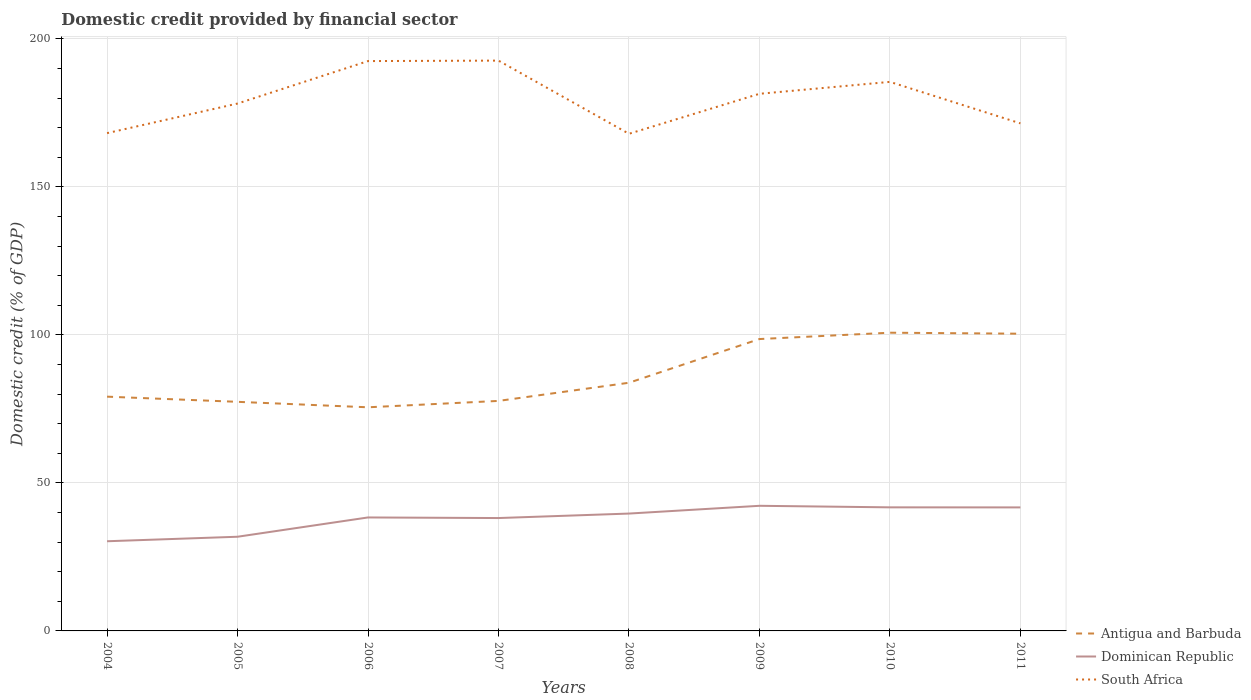How many different coloured lines are there?
Provide a short and direct response. 3. Is the number of lines equal to the number of legend labels?
Your answer should be compact. Yes. Across all years, what is the maximum domestic credit in Dominican Republic?
Keep it short and to the point. 30.29. What is the total domestic credit in Antigua and Barbuda in the graph?
Keep it short and to the point. -21.6. What is the difference between the highest and the second highest domestic credit in South Africa?
Provide a succinct answer. 24.72. What is the difference between the highest and the lowest domestic credit in Dominican Republic?
Offer a terse response. 6. Is the domestic credit in Dominican Republic strictly greater than the domestic credit in South Africa over the years?
Give a very brief answer. Yes. How many lines are there?
Keep it short and to the point. 3. Where does the legend appear in the graph?
Your response must be concise. Bottom right. How many legend labels are there?
Make the answer very short. 3. How are the legend labels stacked?
Your response must be concise. Vertical. What is the title of the graph?
Your answer should be compact. Domestic credit provided by financial sector. What is the label or title of the Y-axis?
Make the answer very short. Domestic credit (% of GDP). What is the Domestic credit (% of GDP) in Antigua and Barbuda in 2004?
Your answer should be compact. 79.14. What is the Domestic credit (% of GDP) of Dominican Republic in 2004?
Give a very brief answer. 30.29. What is the Domestic credit (% of GDP) in South Africa in 2004?
Offer a terse response. 168.16. What is the Domestic credit (% of GDP) in Antigua and Barbuda in 2005?
Offer a terse response. 77.39. What is the Domestic credit (% of GDP) of Dominican Republic in 2005?
Your answer should be very brief. 31.81. What is the Domestic credit (% of GDP) of South Africa in 2005?
Keep it short and to the point. 178.16. What is the Domestic credit (% of GDP) in Antigua and Barbuda in 2006?
Your answer should be very brief. 75.54. What is the Domestic credit (% of GDP) in Dominican Republic in 2006?
Offer a terse response. 38.33. What is the Domestic credit (% of GDP) of South Africa in 2006?
Give a very brief answer. 192.5. What is the Domestic credit (% of GDP) of Antigua and Barbuda in 2007?
Keep it short and to the point. 77.7. What is the Domestic credit (% of GDP) in Dominican Republic in 2007?
Provide a succinct answer. 38.13. What is the Domestic credit (% of GDP) in South Africa in 2007?
Provide a short and direct response. 192.66. What is the Domestic credit (% of GDP) of Antigua and Barbuda in 2008?
Your answer should be very brief. 83.84. What is the Domestic credit (% of GDP) of Dominican Republic in 2008?
Keep it short and to the point. 39.64. What is the Domestic credit (% of GDP) in South Africa in 2008?
Your answer should be very brief. 167.94. What is the Domestic credit (% of GDP) in Antigua and Barbuda in 2009?
Provide a succinct answer. 98.6. What is the Domestic credit (% of GDP) in Dominican Republic in 2009?
Make the answer very short. 42.27. What is the Domestic credit (% of GDP) of South Africa in 2009?
Your answer should be compact. 181.45. What is the Domestic credit (% of GDP) in Antigua and Barbuda in 2010?
Keep it short and to the point. 100.74. What is the Domestic credit (% of GDP) in Dominican Republic in 2010?
Your answer should be very brief. 41.74. What is the Domestic credit (% of GDP) of South Africa in 2010?
Ensure brevity in your answer.  185.47. What is the Domestic credit (% of GDP) in Antigua and Barbuda in 2011?
Provide a succinct answer. 100.4. What is the Domestic credit (% of GDP) in Dominican Republic in 2011?
Your answer should be very brief. 41.72. What is the Domestic credit (% of GDP) in South Africa in 2011?
Your answer should be very brief. 171.46. Across all years, what is the maximum Domestic credit (% of GDP) in Antigua and Barbuda?
Your answer should be compact. 100.74. Across all years, what is the maximum Domestic credit (% of GDP) in Dominican Republic?
Your response must be concise. 42.27. Across all years, what is the maximum Domestic credit (% of GDP) of South Africa?
Offer a very short reply. 192.66. Across all years, what is the minimum Domestic credit (% of GDP) in Antigua and Barbuda?
Your response must be concise. 75.54. Across all years, what is the minimum Domestic credit (% of GDP) in Dominican Republic?
Ensure brevity in your answer.  30.29. Across all years, what is the minimum Domestic credit (% of GDP) in South Africa?
Keep it short and to the point. 167.94. What is the total Domestic credit (% of GDP) in Antigua and Barbuda in the graph?
Your answer should be very brief. 693.36. What is the total Domestic credit (% of GDP) of Dominican Republic in the graph?
Make the answer very short. 303.95. What is the total Domestic credit (% of GDP) in South Africa in the graph?
Offer a very short reply. 1437.81. What is the difference between the Domestic credit (% of GDP) in Antigua and Barbuda in 2004 and that in 2005?
Give a very brief answer. 1.74. What is the difference between the Domestic credit (% of GDP) in Dominican Republic in 2004 and that in 2005?
Your answer should be compact. -1.52. What is the difference between the Domestic credit (% of GDP) of South Africa in 2004 and that in 2005?
Give a very brief answer. -10. What is the difference between the Domestic credit (% of GDP) in Antigua and Barbuda in 2004 and that in 2006?
Offer a very short reply. 3.59. What is the difference between the Domestic credit (% of GDP) of Dominican Republic in 2004 and that in 2006?
Your response must be concise. -8.04. What is the difference between the Domestic credit (% of GDP) in South Africa in 2004 and that in 2006?
Provide a succinct answer. -24.34. What is the difference between the Domestic credit (% of GDP) in Antigua and Barbuda in 2004 and that in 2007?
Your answer should be very brief. 1.44. What is the difference between the Domestic credit (% of GDP) in Dominican Republic in 2004 and that in 2007?
Provide a short and direct response. -7.84. What is the difference between the Domestic credit (% of GDP) in South Africa in 2004 and that in 2007?
Offer a very short reply. -24.5. What is the difference between the Domestic credit (% of GDP) in Antigua and Barbuda in 2004 and that in 2008?
Offer a terse response. -4.7. What is the difference between the Domestic credit (% of GDP) of Dominican Republic in 2004 and that in 2008?
Your response must be concise. -9.35. What is the difference between the Domestic credit (% of GDP) of South Africa in 2004 and that in 2008?
Your answer should be compact. 0.22. What is the difference between the Domestic credit (% of GDP) of Antigua and Barbuda in 2004 and that in 2009?
Make the answer very short. -19.46. What is the difference between the Domestic credit (% of GDP) in Dominican Republic in 2004 and that in 2009?
Give a very brief answer. -11.98. What is the difference between the Domestic credit (% of GDP) in South Africa in 2004 and that in 2009?
Give a very brief answer. -13.29. What is the difference between the Domestic credit (% of GDP) of Antigua and Barbuda in 2004 and that in 2010?
Offer a terse response. -21.6. What is the difference between the Domestic credit (% of GDP) in Dominican Republic in 2004 and that in 2010?
Your response must be concise. -11.45. What is the difference between the Domestic credit (% of GDP) of South Africa in 2004 and that in 2010?
Provide a succinct answer. -17.31. What is the difference between the Domestic credit (% of GDP) in Antigua and Barbuda in 2004 and that in 2011?
Make the answer very short. -21.27. What is the difference between the Domestic credit (% of GDP) of Dominican Republic in 2004 and that in 2011?
Provide a short and direct response. -11.43. What is the difference between the Domestic credit (% of GDP) of South Africa in 2004 and that in 2011?
Offer a very short reply. -3.3. What is the difference between the Domestic credit (% of GDP) of Antigua and Barbuda in 2005 and that in 2006?
Offer a very short reply. 1.85. What is the difference between the Domestic credit (% of GDP) of Dominican Republic in 2005 and that in 2006?
Provide a succinct answer. -6.52. What is the difference between the Domestic credit (% of GDP) of South Africa in 2005 and that in 2006?
Offer a terse response. -14.35. What is the difference between the Domestic credit (% of GDP) in Antigua and Barbuda in 2005 and that in 2007?
Provide a short and direct response. -0.31. What is the difference between the Domestic credit (% of GDP) in Dominican Republic in 2005 and that in 2007?
Offer a terse response. -6.32. What is the difference between the Domestic credit (% of GDP) of South Africa in 2005 and that in 2007?
Provide a short and direct response. -14.5. What is the difference between the Domestic credit (% of GDP) of Antigua and Barbuda in 2005 and that in 2008?
Make the answer very short. -6.44. What is the difference between the Domestic credit (% of GDP) of Dominican Republic in 2005 and that in 2008?
Your answer should be very brief. -7.83. What is the difference between the Domestic credit (% of GDP) in South Africa in 2005 and that in 2008?
Offer a very short reply. 10.21. What is the difference between the Domestic credit (% of GDP) in Antigua and Barbuda in 2005 and that in 2009?
Offer a very short reply. -21.21. What is the difference between the Domestic credit (% of GDP) of Dominican Republic in 2005 and that in 2009?
Your answer should be compact. -10.45. What is the difference between the Domestic credit (% of GDP) in South Africa in 2005 and that in 2009?
Your response must be concise. -3.29. What is the difference between the Domestic credit (% of GDP) in Antigua and Barbuda in 2005 and that in 2010?
Offer a very short reply. -23.35. What is the difference between the Domestic credit (% of GDP) in Dominican Republic in 2005 and that in 2010?
Offer a terse response. -9.93. What is the difference between the Domestic credit (% of GDP) in South Africa in 2005 and that in 2010?
Make the answer very short. -7.32. What is the difference between the Domestic credit (% of GDP) in Antigua and Barbuda in 2005 and that in 2011?
Provide a short and direct response. -23.01. What is the difference between the Domestic credit (% of GDP) of Dominican Republic in 2005 and that in 2011?
Your answer should be compact. -9.91. What is the difference between the Domestic credit (% of GDP) of South Africa in 2005 and that in 2011?
Ensure brevity in your answer.  6.69. What is the difference between the Domestic credit (% of GDP) in Antigua and Barbuda in 2006 and that in 2007?
Give a very brief answer. -2.16. What is the difference between the Domestic credit (% of GDP) in Dominican Republic in 2006 and that in 2007?
Your response must be concise. 0.2. What is the difference between the Domestic credit (% of GDP) of South Africa in 2006 and that in 2007?
Make the answer very short. -0.16. What is the difference between the Domestic credit (% of GDP) of Antigua and Barbuda in 2006 and that in 2008?
Provide a succinct answer. -8.29. What is the difference between the Domestic credit (% of GDP) of Dominican Republic in 2006 and that in 2008?
Your answer should be very brief. -1.31. What is the difference between the Domestic credit (% of GDP) in South Africa in 2006 and that in 2008?
Your response must be concise. 24.56. What is the difference between the Domestic credit (% of GDP) of Antigua and Barbuda in 2006 and that in 2009?
Your response must be concise. -23.05. What is the difference between the Domestic credit (% of GDP) of Dominican Republic in 2006 and that in 2009?
Provide a succinct answer. -3.93. What is the difference between the Domestic credit (% of GDP) in South Africa in 2006 and that in 2009?
Keep it short and to the point. 11.05. What is the difference between the Domestic credit (% of GDP) in Antigua and Barbuda in 2006 and that in 2010?
Your response must be concise. -25.2. What is the difference between the Domestic credit (% of GDP) of Dominican Republic in 2006 and that in 2010?
Ensure brevity in your answer.  -3.41. What is the difference between the Domestic credit (% of GDP) of South Africa in 2006 and that in 2010?
Your answer should be very brief. 7.03. What is the difference between the Domestic credit (% of GDP) in Antigua and Barbuda in 2006 and that in 2011?
Ensure brevity in your answer.  -24.86. What is the difference between the Domestic credit (% of GDP) in Dominican Republic in 2006 and that in 2011?
Your response must be concise. -3.39. What is the difference between the Domestic credit (% of GDP) of South Africa in 2006 and that in 2011?
Provide a short and direct response. 21.04. What is the difference between the Domestic credit (% of GDP) in Antigua and Barbuda in 2007 and that in 2008?
Offer a very short reply. -6.14. What is the difference between the Domestic credit (% of GDP) in Dominican Republic in 2007 and that in 2008?
Make the answer very short. -1.51. What is the difference between the Domestic credit (% of GDP) of South Africa in 2007 and that in 2008?
Keep it short and to the point. 24.72. What is the difference between the Domestic credit (% of GDP) in Antigua and Barbuda in 2007 and that in 2009?
Provide a short and direct response. -20.9. What is the difference between the Domestic credit (% of GDP) of Dominican Republic in 2007 and that in 2009?
Your response must be concise. -4.13. What is the difference between the Domestic credit (% of GDP) of South Africa in 2007 and that in 2009?
Your answer should be compact. 11.21. What is the difference between the Domestic credit (% of GDP) in Antigua and Barbuda in 2007 and that in 2010?
Offer a terse response. -23.04. What is the difference between the Domestic credit (% of GDP) of Dominican Republic in 2007 and that in 2010?
Ensure brevity in your answer.  -3.61. What is the difference between the Domestic credit (% of GDP) of South Africa in 2007 and that in 2010?
Provide a short and direct response. 7.19. What is the difference between the Domestic credit (% of GDP) in Antigua and Barbuda in 2007 and that in 2011?
Provide a succinct answer. -22.7. What is the difference between the Domestic credit (% of GDP) of Dominican Republic in 2007 and that in 2011?
Your response must be concise. -3.59. What is the difference between the Domestic credit (% of GDP) of South Africa in 2007 and that in 2011?
Your answer should be compact. 21.2. What is the difference between the Domestic credit (% of GDP) of Antigua and Barbuda in 2008 and that in 2009?
Ensure brevity in your answer.  -14.76. What is the difference between the Domestic credit (% of GDP) of Dominican Republic in 2008 and that in 2009?
Keep it short and to the point. -2.62. What is the difference between the Domestic credit (% of GDP) of South Africa in 2008 and that in 2009?
Ensure brevity in your answer.  -13.51. What is the difference between the Domestic credit (% of GDP) in Antigua and Barbuda in 2008 and that in 2010?
Your answer should be compact. -16.9. What is the difference between the Domestic credit (% of GDP) of Dominican Republic in 2008 and that in 2010?
Ensure brevity in your answer.  -2.1. What is the difference between the Domestic credit (% of GDP) in South Africa in 2008 and that in 2010?
Your answer should be very brief. -17.53. What is the difference between the Domestic credit (% of GDP) in Antigua and Barbuda in 2008 and that in 2011?
Your answer should be very brief. -16.57. What is the difference between the Domestic credit (% of GDP) in Dominican Republic in 2008 and that in 2011?
Make the answer very short. -2.08. What is the difference between the Domestic credit (% of GDP) in South Africa in 2008 and that in 2011?
Your answer should be very brief. -3.52. What is the difference between the Domestic credit (% of GDP) of Antigua and Barbuda in 2009 and that in 2010?
Offer a very short reply. -2.14. What is the difference between the Domestic credit (% of GDP) in Dominican Republic in 2009 and that in 2010?
Provide a succinct answer. 0.52. What is the difference between the Domestic credit (% of GDP) of South Africa in 2009 and that in 2010?
Your answer should be very brief. -4.02. What is the difference between the Domestic credit (% of GDP) in Antigua and Barbuda in 2009 and that in 2011?
Your answer should be compact. -1.8. What is the difference between the Domestic credit (% of GDP) in Dominican Republic in 2009 and that in 2011?
Offer a terse response. 0.54. What is the difference between the Domestic credit (% of GDP) of South Africa in 2009 and that in 2011?
Ensure brevity in your answer.  9.99. What is the difference between the Domestic credit (% of GDP) in Antigua and Barbuda in 2010 and that in 2011?
Ensure brevity in your answer.  0.34. What is the difference between the Domestic credit (% of GDP) in Dominican Republic in 2010 and that in 2011?
Your response must be concise. 0.02. What is the difference between the Domestic credit (% of GDP) in South Africa in 2010 and that in 2011?
Make the answer very short. 14.01. What is the difference between the Domestic credit (% of GDP) in Antigua and Barbuda in 2004 and the Domestic credit (% of GDP) in Dominican Republic in 2005?
Provide a succinct answer. 47.32. What is the difference between the Domestic credit (% of GDP) of Antigua and Barbuda in 2004 and the Domestic credit (% of GDP) of South Africa in 2005?
Offer a terse response. -99.02. What is the difference between the Domestic credit (% of GDP) in Dominican Republic in 2004 and the Domestic credit (% of GDP) in South Africa in 2005?
Offer a very short reply. -147.86. What is the difference between the Domestic credit (% of GDP) of Antigua and Barbuda in 2004 and the Domestic credit (% of GDP) of Dominican Republic in 2006?
Your response must be concise. 40.8. What is the difference between the Domestic credit (% of GDP) in Antigua and Barbuda in 2004 and the Domestic credit (% of GDP) in South Africa in 2006?
Ensure brevity in your answer.  -113.37. What is the difference between the Domestic credit (% of GDP) of Dominican Republic in 2004 and the Domestic credit (% of GDP) of South Africa in 2006?
Offer a very short reply. -162.21. What is the difference between the Domestic credit (% of GDP) of Antigua and Barbuda in 2004 and the Domestic credit (% of GDP) of Dominican Republic in 2007?
Provide a succinct answer. 41. What is the difference between the Domestic credit (% of GDP) in Antigua and Barbuda in 2004 and the Domestic credit (% of GDP) in South Africa in 2007?
Your answer should be compact. -113.52. What is the difference between the Domestic credit (% of GDP) of Dominican Republic in 2004 and the Domestic credit (% of GDP) of South Africa in 2007?
Your answer should be compact. -162.37. What is the difference between the Domestic credit (% of GDP) of Antigua and Barbuda in 2004 and the Domestic credit (% of GDP) of Dominican Republic in 2008?
Your answer should be compact. 39.49. What is the difference between the Domestic credit (% of GDP) of Antigua and Barbuda in 2004 and the Domestic credit (% of GDP) of South Africa in 2008?
Keep it short and to the point. -88.8. What is the difference between the Domestic credit (% of GDP) in Dominican Republic in 2004 and the Domestic credit (% of GDP) in South Africa in 2008?
Your answer should be very brief. -137.65. What is the difference between the Domestic credit (% of GDP) in Antigua and Barbuda in 2004 and the Domestic credit (% of GDP) in Dominican Republic in 2009?
Your answer should be very brief. 36.87. What is the difference between the Domestic credit (% of GDP) of Antigua and Barbuda in 2004 and the Domestic credit (% of GDP) of South Africa in 2009?
Provide a short and direct response. -102.31. What is the difference between the Domestic credit (% of GDP) of Dominican Republic in 2004 and the Domestic credit (% of GDP) of South Africa in 2009?
Make the answer very short. -151.16. What is the difference between the Domestic credit (% of GDP) of Antigua and Barbuda in 2004 and the Domestic credit (% of GDP) of Dominican Republic in 2010?
Ensure brevity in your answer.  37.39. What is the difference between the Domestic credit (% of GDP) in Antigua and Barbuda in 2004 and the Domestic credit (% of GDP) in South Africa in 2010?
Your answer should be very brief. -106.34. What is the difference between the Domestic credit (% of GDP) in Dominican Republic in 2004 and the Domestic credit (% of GDP) in South Africa in 2010?
Offer a terse response. -155.18. What is the difference between the Domestic credit (% of GDP) in Antigua and Barbuda in 2004 and the Domestic credit (% of GDP) in Dominican Republic in 2011?
Offer a terse response. 37.41. What is the difference between the Domestic credit (% of GDP) of Antigua and Barbuda in 2004 and the Domestic credit (% of GDP) of South Africa in 2011?
Your answer should be compact. -92.33. What is the difference between the Domestic credit (% of GDP) in Dominican Republic in 2004 and the Domestic credit (% of GDP) in South Africa in 2011?
Your answer should be very brief. -141.17. What is the difference between the Domestic credit (% of GDP) in Antigua and Barbuda in 2005 and the Domestic credit (% of GDP) in Dominican Republic in 2006?
Your answer should be very brief. 39.06. What is the difference between the Domestic credit (% of GDP) of Antigua and Barbuda in 2005 and the Domestic credit (% of GDP) of South Africa in 2006?
Give a very brief answer. -115.11. What is the difference between the Domestic credit (% of GDP) in Dominican Republic in 2005 and the Domestic credit (% of GDP) in South Africa in 2006?
Your answer should be very brief. -160.69. What is the difference between the Domestic credit (% of GDP) in Antigua and Barbuda in 2005 and the Domestic credit (% of GDP) in Dominican Republic in 2007?
Offer a terse response. 39.26. What is the difference between the Domestic credit (% of GDP) in Antigua and Barbuda in 2005 and the Domestic credit (% of GDP) in South Africa in 2007?
Give a very brief answer. -115.27. What is the difference between the Domestic credit (% of GDP) in Dominican Republic in 2005 and the Domestic credit (% of GDP) in South Africa in 2007?
Your answer should be very brief. -160.85. What is the difference between the Domestic credit (% of GDP) of Antigua and Barbuda in 2005 and the Domestic credit (% of GDP) of Dominican Republic in 2008?
Provide a succinct answer. 37.75. What is the difference between the Domestic credit (% of GDP) of Antigua and Barbuda in 2005 and the Domestic credit (% of GDP) of South Africa in 2008?
Make the answer very short. -90.55. What is the difference between the Domestic credit (% of GDP) in Dominican Republic in 2005 and the Domestic credit (% of GDP) in South Africa in 2008?
Give a very brief answer. -136.13. What is the difference between the Domestic credit (% of GDP) of Antigua and Barbuda in 2005 and the Domestic credit (% of GDP) of Dominican Republic in 2009?
Your answer should be compact. 35.13. What is the difference between the Domestic credit (% of GDP) in Antigua and Barbuda in 2005 and the Domestic credit (% of GDP) in South Africa in 2009?
Provide a succinct answer. -104.06. What is the difference between the Domestic credit (% of GDP) of Dominican Republic in 2005 and the Domestic credit (% of GDP) of South Africa in 2009?
Keep it short and to the point. -149.64. What is the difference between the Domestic credit (% of GDP) in Antigua and Barbuda in 2005 and the Domestic credit (% of GDP) in Dominican Republic in 2010?
Make the answer very short. 35.65. What is the difference between the Domestic credit (% of GDP) in Antigua and Barbuda in 2005 and the Domestic credit (% of GDP) in South Africa in 2010?
Keep it short and to the point. -108.08. What is the difference between the Domestic credit (% of GDP) of Dominican Republic in 2005 and the Domestic credit (% of GDP) of South Africa in 2010?
Provide a short and direct response. -153.66. What is the difference between the Domestic credit (% of GDP) of Antigua and Barbuda in 2005 and the Domestic credit (% of GDP) of Dominican Republic in 2011?
Your answer should be very brief. 35.67. What is the difference between the Domestic credit (% of GDP) of Antigua and Barbuda in 2005 and the Domestic credit (% of GDP) of South Africa in 2011?
Your response must be concise. -94.07. What is the difference between the Domestic credit (% of GDP) of Dominican Republic in 2005 and the Domestic credit (% of GDP) of South Africa in 2011?
Provide a succinct answer. -139.65. What is the difference between the Domestic credit (% of GDP) of Antigua and Barbuda in 2006 and the Domestic credit (% of GDP) of Dominican Republic in 2007?
Give a very brief answer. 37.41. What is the difference between the Domestic credit (% of GDP) in Antigua and Barbuda in 2006 and the Domestic credit (% of GDP) in South Africa in 2007?
Provide a short and direct response. -117.12. What is the difference between the Domestic credit (% of GDP) of Dominican Republic in 2006 and the Domestic credit (% of GDP) of South Africa in 2007?
Your response must be concise. -154.33. What is the difference between the Domestic credit (% of GDP) of Antigua and Barbuda in 2006 and the Domestic credit (% of GDP) of Dominican Republic in 2008?
Make the answer very short. 35.9. What is the difference between the Domestic credit (% of GDP) in Antigua and Barbuda in 2006 and the Domestic credit (% of GDP) in South Africa in 2008?
Provide a succinct answer. -92.4. What is the difference between the Domestic credit (% of GDP) in Dominican Republic in 2006 and the Domestic credit (% of GDP) in South Africa in 2008?
Keep it short and to the point. -129.61. What is the difference between the Domestic credit (% of GDP) of Antigua and Barbuda in 2006 and the Domestic credit (% of GDP) of Dominican Republic in 2009?
Offer a very short reply. 33.28. What is the difference between the Domestic credit (% of GDP) in Antigua and Barbuda in 2006 and the Domestic credit (% of GDP) in South Africa in 2009?
Offer a very short reply. -105.91. What is the difference between the Domestic credit (% of GDP) in Dominican Republic in 2006 and the Domestic credit (% of GDP) in South Africa in 2009?
Provide a short and direct response. -143.12. What is the difference between the Domestic credit (% of GDP) of Antigua and Barbuda in 2006 and the Domestic credit (% of GDP) of Dominican Republic in 2010?
Offer a very short reply. 33.8. What is the difference between the Domestic credit (% of GDP) in Antigua and Barbuda in 2006 and the Domestic credit (% of GDP) in South Africa in 2010?
Your answer should be compact. -109.93. What is the difference between the Domestic credit (% of GDP) in Dominican Republic in 2006 and the Domestic credit (% of GDP) in South Africa in 2010?
Ensure brevity in your answer.  -147.14. What is the difference between the Domestic credit (% of GDP) in Antigua and Barbuda in 2006 and the Domestic credit (% of GDP) in Dominican Republic in 2011?
Offer a very short reply. 33.82. What is the difference between the Domestic credit (% of GDP) in Antigua and Barbuda in 2006 and the Domestic credit (% of GDP) in South Africa in 2011?
Give a very brief answer. -95.92. What is the difference between the Domestic credit (% of GDP) in Dominican Republic in 2006 and the Domestic credit (% of GDP) in South Africa in 2011?
Your response must be concise. -133.13. What is the difference between the Domestic credit (% of GDP) of Antigua and Barbuda in 2007 and the Domestic credit (% of GDP) of Dominican Republic in 2008?
Provide a succinct answer. 38.06. What is the difference between the Domestic credit (% of GDP) of Antigua and Barbuda in 2007 and the Domestic credit (% of GDP) of South Africa in 2008?
Offer a terse response. -90.24. What is the difference between the Domestic credit (% of GDP) of Dominican Republic in 2007 and the Domestic credit (% of GDP) of South Africa in 2008?
Offer a very short reply. -129.81. What is the difference between the Domestic credit (% of GDP) in Antigua and Barbuda in 2007 and the Domestic credit (% of GDP) in Dominican Republic in 2009?
Give a very brief answer. 35.44. What is the difference between the Domestic credit (% of GDP) of Antigua and Barbuda in 2007 and the Domestic credit (% of GDP) of South Africa in 2009?
Ensure brevity in your answer.  -103.75. What is the difference between the Domestic credit (% of GDP) in Dominican Republic in 2007 and the Domestic credit (% of GDP) in South Africa in 2009?
Your response must be concise. -143.32. What is the difference between the Domestic credit (% of GDP) of Antigua and Barbuda in 2007 and the Domestic credit (% of GDP) of Dominican Republic in 2010?
Give a very brief answer. 35.96. What is the difference between the Domestic credit (% of GDP) in Antigua and Barbuda in 2007 and the Domestic credit (% of GDP) in South Africa in 2010?
Offer a terse response. -107.77. What is the difference between the Domestic credit (% of GDP) in Dominican Republic in 2007 and the Domestic credit (% of GDP) in South Africa in 2010?
Make the answer very short. -147.34. What is the difference between the Domestic credit (% of GDP) of Antigua and Barbuda in 2007 and the Domestic credit (% of GDP) of Dominican Republic in 2011?
Your answer should be compact. 35.98. What is the difference between the Domestic credit (% of GDP) in Antigua and Barbuda in 2007 and the Domestic credit (% of GDP) in South Africa in 2011?
Ensure brevity in your answer.  -93.76. What is the difference between the Domestic credit (% of GDP) in Dominican Republic in 2007 and the Domestic credit (% of GDP) in South Africa in 2011?
Your answer should be very brief. -133.33. What is the difference between the Domestic credit (% of GDP) of Antigua and Barbuda in 2008 and the Domestic credit (% of GDP) of Dominican Republic in 2009?
Your answer should be very brief. 41.57. What is the difference between the Domestic credit (% of GDP) in Antigua and Barbuda in 2008 and the Domestic credit (% of GDP) in South Africa in 2009?
Ensure brevity in your answer.  -97.61. What is the difference between the Domestic credit (% of GDP) of Dominican Republic in 2008 and the Domestic credit (% of GDP) of South Africa in 2009?
Provide a succinct answer. -141.81. What is the difference between the Domestic credit (% of GDP) in Antigua and Barbuda in 2008 and the Domestic credit (% of GDP) in Dominican Republic in 2010?
Your response must be concise. 42.09. What is the difference between the Domestic credit (% of GDP) of Antigua and Barbuda in 2008 and the Domestic credit (% of GDP) of South Africa in 2010?
Offer a terse response. -101.64. What is the difference between the Domestic credit (% of GDP) in Dominican Republic in 2008 and the Domestic credit (% of GDP) in South Africa in 2010?
Make the answer very short. -145.83. What is the difference between the Domestic credit (% of GDP) of Antigua and Barbuda in 2008 and the Domestic credit (% of GDP) of Dominican Republic in 2011?
Your answer should be very brief. 42.11. What is the difference between the Domestic credit (% of GDP) of Antigua and Barbuda in 2008 and the Domestic credit (% of GDP) of South Africa in 2011?
Make the answer very short. -87.63. What is the difference between the Domestic credit (% of GDP) in Dominican Republic in 2008 and the Domestic credit (% of GDP) in South Africa in 2011?
Provide a short and direct response. -131.82. What is the difference between the Domestic credit (% of GDP) in Antigua and Barbuda in 2009 and the Domestic credit (% of GDP) in Dominican Republic in 2010?
Provide a short and direct response. 56.86. What is the difference between the Domestic credit (% of GDP) of Antigua and Barbuda in 2009 and the Domestic credit (% of GDP) of South Africa in 2010?
Make the answer very short. -86.88. What is the difference between the Domestic credit (% of GDP) in Dominican Republic in 2009 and the Domestic credit (% of GDP) in South Africa in 2010?
Your answer should be compact. -143.21. What is the difference between the Domestic credit (% of GDP) of Antigua and Barbuda in 2009 and the Domestic credit (% of GDP) of Dominican Republic in 2011?
Your response must be concise. 56.88. What is the difference between the Domestic credit (% of GDP) of Antigua and Barbuda in 2009 and the Domestic credit (% of GDP) of South Africa in 2011?
Make the answer very short. -72.86. What is the difference between the Domestic credit (% of GDP) in Dominican Republic in 2009 and the Domestic credit (% of GDP) in South Africa in 2011?
Your answer should be very brief. -129.2. What is the difference between the Domestic credit (% of GDP) of Antigua and Barbuda in 2010 and the Domestic credit (% of GDP) of Dominican Republic in 2011?
Keep it short and to the point. 59.02. What is the difference between the Domestic credit (% of GDP) of Antigua and Barbuda in 2010 and the Domestic credit (% of GDP) of South Africa in 2011?
Provide a short and direct response. -70.72. What is the difference between the Domestic credit (% of GDP) of Dominican Republic in 2010 and the Domestic credit (% of GDP) of South Africa in 2011?
Give a very brief answer. -129.72. What is the average Domestic credit (% of GDP) in Antigua and Barbuda per year?
Your answer should be very brief. 86.67. What is the average Domestic credit (% of GDP) of Dominican Republic per year?
Your answer should be compact. 37.99. What is the average Domestic credit (% of GDP) of South Africa per year?
Keep it short and to the point. 179.73. In the year 2004, what is the difference between the Domestic credit (% of GDP) in Antigua and Barbuda and Domestic credit (% of GDP) in Dominican Republic?
Your answer should be very brief. 48.85. In the year 2004, what is the difference between the Domestic credit (% of GDP) of Antigua and Barbuda and Domestic credit (% of GDP) of South Africa?
Provide a succinct answer. -89.02. In the year 2004, what is the difference between the Domestic credit (% of GDP) of Dominican Republic and Domestic credit (% of GDP) of South Africa?
Ensure brevity in your answer.  -137.87. In the year 2005, what is the difference between the Domestic credit (% of GDP) in Antigua and Barbuda and Domestic credit (% of GDP) in Dominican Republic?
Provide a succinct answer. 45.58. In the year 2005, what is the difference between the Domestic credit (% of GDP) of Antigua and Barbuda and Domestic credit (% of GDP) of South Africa?
Your answer should be compact. -100.76. In the year 2005, what is the difference between the Domestic credit (% of GDP) in Dominican Republic and Domestic credit (% of GDP) in South Africa?
Offer a terse response. -146.34. In the year 2006, what is the difference between the Domestic credit (% of GDP) in Antigua and Barbuda and Domestic credit (% of GDP) in Dominican Republic?
Offer a terse response. 37.21. In the year 2006, what is the difference between the Domestic credit (% of GDP) of Antigua and Barbuda and Domestic credit (% of GDP) of South Africa?
Keep it short and to the point. -116.96. In the year 2006, what is the difference between the Domestic credit (% of GDP) in Dominican Republic and Domestic credit (% of GDP) in South Africa?
Your response must be concise. -154.17. In the year 2007, what is the difference between the Domestic credit (% of GDP) of Antigua and Barbuda and Domestic credit (% of GDP) of Dominican Republic?
Your response must be concise. 39.57. In the year 2007, what is the difference between the Domestic credit (% of GDP) of Antigua and Barbuda and Domestic credit (% of GDP) of South Africa?
Ensure brevity in your answer.  -114.96. In the year 2007, what is the difference between the Domestic credit (% of GDP) in Dominican Republic and Domestic credit (% of GDP) in South Africa?
Your answer should be very brief. -154.53. In the year 2008, what is the difference between the Domestic credit (% of GDP) in Antigua and Barbuda and Domestic credit (% of GDP) in Dominican Republic?
Provide a succinct answer. 44.19. In the year 2008, what is the difference between the Domestic credit (% of GDP) in Antigua and Barbuda and Domestic credit (% of GDP) in South Africa?
Offer a terse response. -84.1. In the year 2008, what is the difference between the Domestic credit (% of GDP) in Dominican Republic and Domestic credit (% of GDP) in South Africa?
Your response must be concise. -128.3. In the year 2009, what is the difference between the Domestic credit (% of GDP) in Antigua and Barbuda and Domestic credit (% of GDP) in Dominican Republic?
Keep it short and to the point. 56.33. In the year 2009, what is the difference between the Domestic credit (% of GDP) in Antigua and Barbuda and Domestic credit (% of GDP) in South Africa?
Provide a short and direct response. -82.85. In the year 2009, what is the difference between the Domestic credit (% of GDP) in Dominican Republic and Domestic credit (% of GDP) in South Africa?
Your response must be concise. -139.18. In the year 2010, what is the difference between the Domestic credit (% of GDP) of Antigua and Barbuda and Domestic credit (% of GDP) of Dominican Republic?
Give a very brief answer. 59. In the year 2010, what is the difference between the Domestic credit (% of GDP) of Antigua and Barbuda and Domestic credit (% of GDP) of South Africa?
Ensure brevity in your answer.  -84.73. In the year 2010, what is the difference between the Domestic credit (% of GDP) in Dominican Republic and Domestic credit (% of GDP) in South Africa?
Ensure brevity in your answer.  -143.73. In the year 2011, what is the difference between the Domestic credit (% of GDP) of Antigua and Barbuda and Domestic credit (% of GDP) of Dominican Republic?
Your answer should be very brief. 58.68. In the year 2011, what is the difference between the Domestic credit (% of GDP) in Antigua and Barbuda and Domestic credit (% of GDP) in South Africa?
Give a very brief answer. -71.06. In the year 2011, what is the difference between the Domestic credit (% of GDP) in Dominican Republic and Domestic credit (% of GDP) in South Africa?
Keep it short and to the point. -129.74. What is the ratio of the Domestic credit (% of GDP) of Antigua and Barbuda in 2004 to that in 2005?
Your response must be concise. 1.02. What is the ratio of the Domestic credit (% of GDP) in Dominican Republic in 2004 to that in 2005?
Make the answer very short. 0.95. What is the ratio of the Domestic credit (% of GDP) of South Africa in 2004 to that in 2005?
Make the answer very short. 0.94. What is the ratio of the Domestic credit (% of GDP) in Antigua and Barbuda in 2004 to that in 2006?
Ensure brevity in your answer.  1.05. What is the ratio of the Domestic credit (% of GDP) in Dominican Republic in 2004 to that in 2006?
Ensure brevity in your answer.  0.79. What is the ratio of the Domestic credit (% of GDP) of South Africa in 2004 to that in 2006?
Your answer should be compact. 0.87. What is the ratio of the Domestic credit (% of GDP) in Antigua and Barbuda in 2004 to that in 2007?
Offer a very short reply. 1.02. What is the ratio of the Domestic credit (% of GDP) of Dominican Republic in 2004 to that in 2007?
Your answer should be very brief. 0.79. What is the ratio of the Domestic credit (% of GDP) of South Africa in 2004 to that in 2007?
Offer a very short reply. 0.87. What is the ratio of the Domestic credit (% of GDP) in Antigua and Barbuda in 2004 to that in 2008?
Provide a short and direct response. 0.94. What is the ratio of the Domestic credit (% of GDP) in Dominican Republic in 2004 to that in 2008?
Your answer should be very brief. 0.76. What is the ratio of the Domestic credit (% of GDP) in Antigua and Barbuda in 2004 to that in 2009?
Your response must be concise. 0.8. What is the ratio of the Domestic credit (% of GDP) of Dominican Republic in 2004 to that in 2009?
Give a very brief answer. 0.72. What is the ratio of the Domestic credit (% of GDP) in South Africa in 2004 to that in 2009?
Provide a succinct answer. 0.93. What is the ratio of the Domestic credit (% of GDP) of Antigua and Barbuda in 2004 to that in 2010?
Ensure brevity in your answer.  0.79. What is the ratio of the Domestic credit (% of GDP) in Dominican Republic in 2004 to that in 2010?
Keep it short and to the point. 0.73. What is the ratio of the Domestic credit (% of GDP) in South Africa in 2004 to that in 2010?
Your answer should be compact. 0.91. What is the ratio of the Domestic credit (% of GDP) of Antigua and Barbuda in 2004 to that in 2011?
Keep it short and to the point. 0.79. What is the ratio of the Domestic credit (% of GDP) of Dominican Republic in 2004 to that in 2011?
Your answer should be compact. 0.73. What is the ratio of the Domestic credit (% of GDP) in South Africa in 2004 to that in 2011?
Make the answer very short. 0.98. What is the ratio of the Domestic credit (% of GDP) of Antigua and Barbuda in 2005 to that in 2006?
Offer a very short reply. 1.02. What is the ratio of the Domestic credit (% of GDP) in Dominican Republic in 2005 to that in 2006?
Provide a short and direct response. 0.83. What is the ratio of the Domestic credit (% of GDP) in South Africa in 2005 to that in 2006?
Provide a short and direct response. 0.93. What is the ratio of the Domestic credit (% of GDP) of Antigua and Barbuda in 2005 to that in 2007?
Provide a succinct answer. 1. What is the ratio of the Domestic credit (% of GDP) of Dominican Republic in 2005 to that in 2007?
Provide a succinct answer. 0.83. What is the ratio of the Domestic credit (% of GDP) in South Africa in 2005 to that in 2007?
Offer a terse response. 0.92. What is the ratio of the Domestic credit (% of GDP) of Antigua and Barbuda in 2005 to that in 2008?
Keep it short and to the point. 0.92. What is the ratio of the Domestic credit (% of GDP) of Dominican Republic in 2005 to that in 2008?
Your answer should be compact. 0.8. What is the ratio of the Domestic credit (% of GDP) of South Africa in 2005 to that in 2008?
Give a very brief answer. 1.06. What is the ratio of the Domestic credit (% of GDP) in Antigua and Barbuda in 2005 to that in 2009?
Your response must be concise. 0.78. What is the ratio of the Domestic credit (% of GDP) in Dominican Republic in 2005 to that in 2009?
Offer a very short reply. 0.75. What is the ratio of the Domestic credit (% of GDP) in South Africa in 2005 to that in 2009?
Ensure brevity in your answer.  0.98. What is the ratio of the Domestic credit (% of GDP) in Antigua and Barbuda in 2005 to that in 2010?
Your response must be concise. 0.77. What is the ratio of the Domestic credit (% of GDP) in Dominican Republic in 2005 to that in 2010?
Offer a terse response. 0.76. What is the ratio of the Domestic credit (% of GDP) in South Africa in 2005 to that in 2010?
Your answer should be very brief. 0.96. What is the ratio of the Domestic credit (% of GDP) in Antigua and Barbuda in 2005 to that in 2011?
Give a very brief answer. 0.77. What is the ratio of the Domestic credit (% of GDP) in Dominican Republic in 2005 to that in 2011?
Provide a succinct answer. 0.76. What is the ratio of the Domestic credit (% of GDP) of South Africa in 2005 to that in 2011?
Offer a very short reply. 1.04. What is the ratio of the Domestic credit (% of GDP) in Antigua and Barbuda in 2006 to that in 2007?
Your answer should be very brief. 0.97. What is the ratio of the Domestic credit (% of GDP) of Antigua and Barbuda in 2006 to that in 2008?
Keep it short and to the point. 0.9. What is the ratio of the Domestic credit (% of GDP) in Dominican Republic in 2006 to that in 2008?
Your answer should be compact. 0.97. What is the ratio of the Domestic credit (% of GDP) of South Africa in 2006 to that in 2008?
Your answer should be very brief. 1.15. What is the ratio of the Domestic credit (% of GDP) of Antigua and Barbuda in 2006 to that in 2009?
Your answer should be compact. 0.77. What is the ratio of the Domestic credit (% of GDP) in Dominican Republic in 2006 to that in 2009?
Offer a terse response. 0.91. What is the ratio of the Domestic credit (% of GDP) of South Africa in 2006 to that in 2009?
Your answer should be very brief. 1.06. What is the ratio of the Domestic credit (% of GDP) in Antigua and Barbuda in 2006 to that in 2010?
Your answer should be compact. 0.75. What is the ratio of the Domestic credit (% of GDP) in Dominican Republic in 2006 to that in 2010?
Provide a succinct answer. 0.92. What is the ratio of the Domestic credit (% of GDP) of South Africa in 2006 to that in 2010?
Your answer should be very brief. 1.04. What is the ratio of the Domestic credit (% of GDP) in Antigua and Barbuda in 2006 to that in 2011?
Offer a very short reply. 0.75. What is the ratio of the Domestic credit (% of GDP) of Dominican Republic in 2006 to that in 2011?
Your answer should be very brief. 0.92. What is the ratio of the Domestic credit (% of GDP) in South Africa in 2006 to that in 2011?
Ensure brevity in your answer.  1.12. What is the ratio of the Domestic credit (% of GDP) in Antigua and Barbuda in 2007 to that in 2008?
Your response must be concise. 0.93. What is the ratio of the Domestic credit (% of GDP) in Dominican Republic in 2007 to that in 2008?
Offer a very short reply. 0.96. What is the ratio of the Domestic credit (% of GDP) of South Africa in 2007 to that in 2008?
Give a very brief answer. 1.15. What is the ratio of the Domestic credit (% of GDP) of Antigua and Barbuda in 2007 to that in 2009?
Keep it short and to the point. 0.79. What is the ratio of the Domestic credit (% of GDP) of Dominican Republic in 2007 to that in 2009?
Your response must be concise. 0.9. What is the ratio of the Domestic credit (% of GDP) of South Africa in 2007 to that in 2009?
Provide a short and direct response. 1.06. What is the ratio of the Domestic credit (% of GDP) of Antigua and Barbuda in 2007 to that in 2010?
Your answer should be very brief. 0.77. What is the ratio of the Domestic credit (% of GDP) in Dominican Republic in 2007 to that in 2010?
Your answer should be compact. 0.91. What is the ratio of the Domestic credit (% of GDP) in South Africa in 2007 to that in 2010?
Provide a succinct answer. 1.04. What is the ratio of the Domestic credit (% of GDP) of Antigua and Barbuda in 2007 to that in 2011?
Your answer should be very brief. 0.77. What is the ratio of the Domestic credit (% of GDP) of Dominican Republic in 2007 to that in 2011?
Your answer should be very brief. 0.91. What is the ratio of the Domestic credit (% of GDP) of South Africa in 2007 to that in 2011?
Provide a succinct answer. 1.12. What is the ratio of the Domestic credit (% of GDP) of Antigua and Barbuda in 2008 to that in 2009?
Make the answer very short. 0.85. What is the ratio of the Domestic credit (% of GDP) in Dominican Republic in 2008 to that in 2009?
Offer a very short reply. 0.94. What is the ratio of the Domestic credit (% of GDP) in South Africa in 2008 to that in 2009?
Offer a terse response. 0.93. What is the ratio of the Domestic credit (% of GDP) in Antigua and Barbuda in 2008 to that in 2010?
Your response must be concise. 0.83. What is the ratio of the Domestic credit (% of GDP) of Dominican Republic in 2008 to that in 2010?
Your response must be concise. 0.95. What is the ratio of the Domestic credit (% of GDP) of South Africa in 2008 to that in 2010?
Your response must be concise. 0.91. What is the ratio of the Domestic credit (% of GDP) in Antigua and Barbuda in 2008 to that in 2011?
Ensure brevity in your answer.  0.83. What is the ratio of the Domestic credit (% of GDP) of Dominican Republic in 2008 to that in 2011?
Provide a short and direct response. 0.95. What is the ratio of the Domestic credit (% of GDP) of South Africa in 2008 to that in 2011?
Your response must be concise. 0.98. What is the ratio of the Domestic credit (% of GDP) of Antigua and Barbuda in 2009 to that in 2010?
Your answer should be compact. 0.98. What is the ratio of the Domestic credit (% of GDP) of Dominican Republic in 2009 to that in 2010?
Give a very brief answer. 1.01. What is the ratio of the Domestic credit (% of GDP) of South Africa in 2009 to that in 2010?
Offer a terse response. 0.98. What is the ratio of the Domestic credit (% of GDP) of South Africa in 2009 to that in 2011?
Your response must be concise. 1.06. What is the ratio of the Domestic credit (% of GDP) in Antigua and Barbuda in 2010 to that in 2011?
Offer a terse response. 1. What is the ratio of the Domestic credit (% of GDP) in Dominican Republic in 2010 to that in 2011?
Your response must be concise. 1. What is the ratio of the Domestic credit (% of GDP) of South Africa in 2010 to that in 2011?
Give a very brief answer. 1.08. What is the difference between the highest and the second highest Domestic credit (% of GDP) in Antigua and Barbuda?
Make the answer very short. 0.34. What is the difference between the highest and the second highest Domestic credit (% of GDP) in Dominican Republic?
Make the answer very short. 0.52. What is the difference between the highest and the second highest Domestic credit (% of GDP) in South Africa?
Offer a terse response. 0.16. What is the difference between the highest and the lowest Domestic credit (% of GDP) of Antigua and Barbuda?
Your answer should be compact. 25.2. What is the difference between the highest and the lowest Domestic credit (% of GDP) of Dominican Republic?
Your answer should be compact. 11.98. What is the difference between the highest and the lowest Domestic credit (% of GDP) of South Africa?
Give a very brief answer. 24.72. 